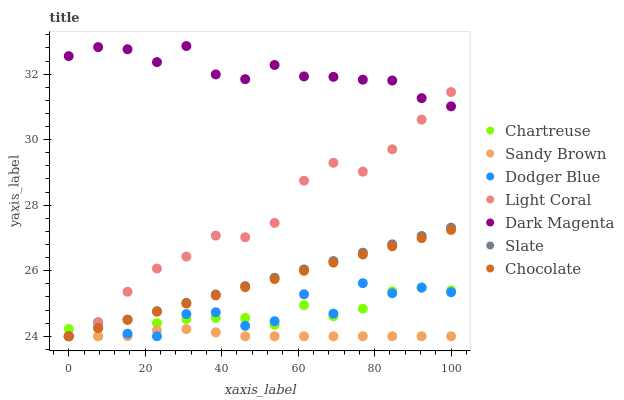Does Sandy Brown have the minimum area under the curve?
Answer yes or no. Yes. Does Dark Magenta have the maximum area under the curve?
Answer yes or no. Yes. Does Slate have the minimum area under the curve?
Answer yes or no. No. Does Slate have the maximum area under the curve?
Answer yes or no. No. Is Chocolate the smoothest?
Answer yes or no. Yes. Is Dodger Blue the roughest?
Answer yes or no. Yes. Is Slate the smoothest?
Answer yes or no. No. Is Slate the roughest?
Answer yes or no. No. Does Slate have the lowest value?
Answer yes or no. Yes. Does Dark Magenta have the highest value?
Answer yes or no. Yes. Does Slate have the highest value?
Answer yes or no. No. Is Sandy Brown less than Dark Magenta?
Answer yes or no. Yes. Is Dark Magenta greater than Dodger Blue?
Answer yes or no. Yes. Does Light Coral intersect Sandy Brown?
Answer yes or no. Yes. Is Light Coral less than Sandy Brown?
Answer yes or no. No. Is Light Coral greater than Sandy Brown?
Answer yes or no. No. Does Sandy Brown intersect Dark Magenta?
Answer yes or no. No. 